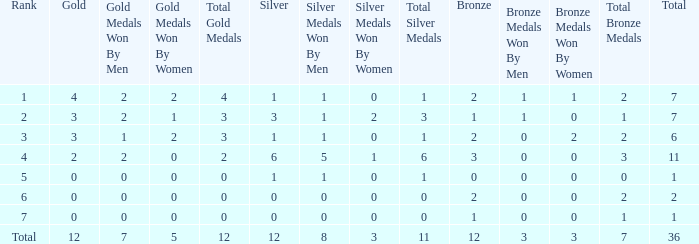What is the largest total for a team with 1 bronze, 0 gold medals and ranking of 7? None. 